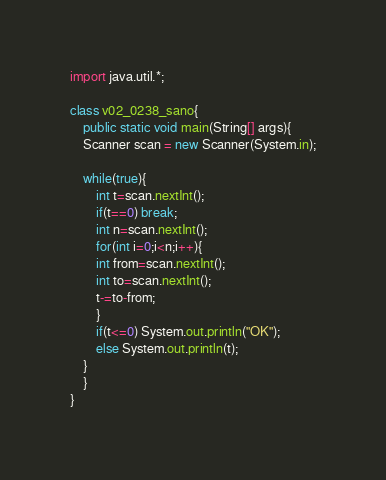Convert code to text. <code><loc_0><loc_0><loc_500><loc_500><_Java_>import java.util.*;

class v02_0238_sano{
    public static void main(String[] args){
	Scanner scan = new Scanner(System.in);

	while(true){
	    int t=scan.nextInt();
	    if(t==0) break;
	    int n=scan.nextInt();
	    for(int i=0;i<n;i++){
		int from=scan.nextInt();
		int to=scan.nextInt();
		t-=to-from;
	    }
	    if(t<=0) System.out.println("OK");
	    else System.out.println(t);
	}
    }
}</code> 